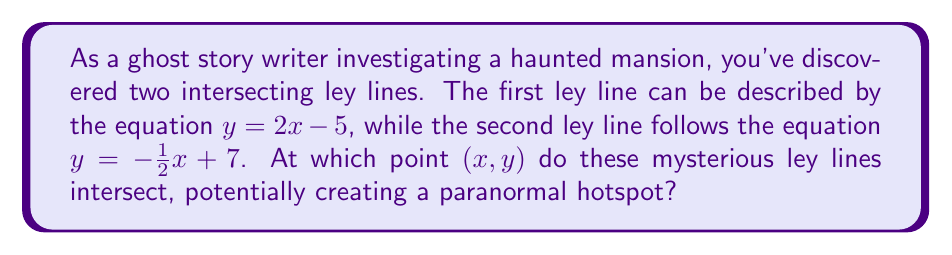Can you solve this math problem? To find the intersection point of the two ley lines, we need to solve the system of equations:

$$\begin{cases}
y = 2x - 5 \\
y = -\frac{1}{2}x + 7
\end{cases}$$

Step 1: Since both equations are equal to $y$, we can set them equal to each other:
$2x - 5 = -\frac{1}{2}x + 7$

Step 2: Add $\frac{1}{2}x$ to both sides:
$\frac{5}{2}x - 5 = 7$

Step 3: Add 5 to both sides:
$\frac{5}{2}x = 12$

Step 4: Multiply both sides by $\frac{2}{5}$:
$x = \frac{24}{5} = 4.8$

Step 5: Substitute this $x$ value into either of the original equations. Let's use $y = 2x - 5$:
$y = 2(4.8) - 5 = 9.6 - 5 = 4.6$

Therefore, the ley lines intersect at the point $(4.8, 4.6)$.
Answer: $(4.8, 4.6)$ 